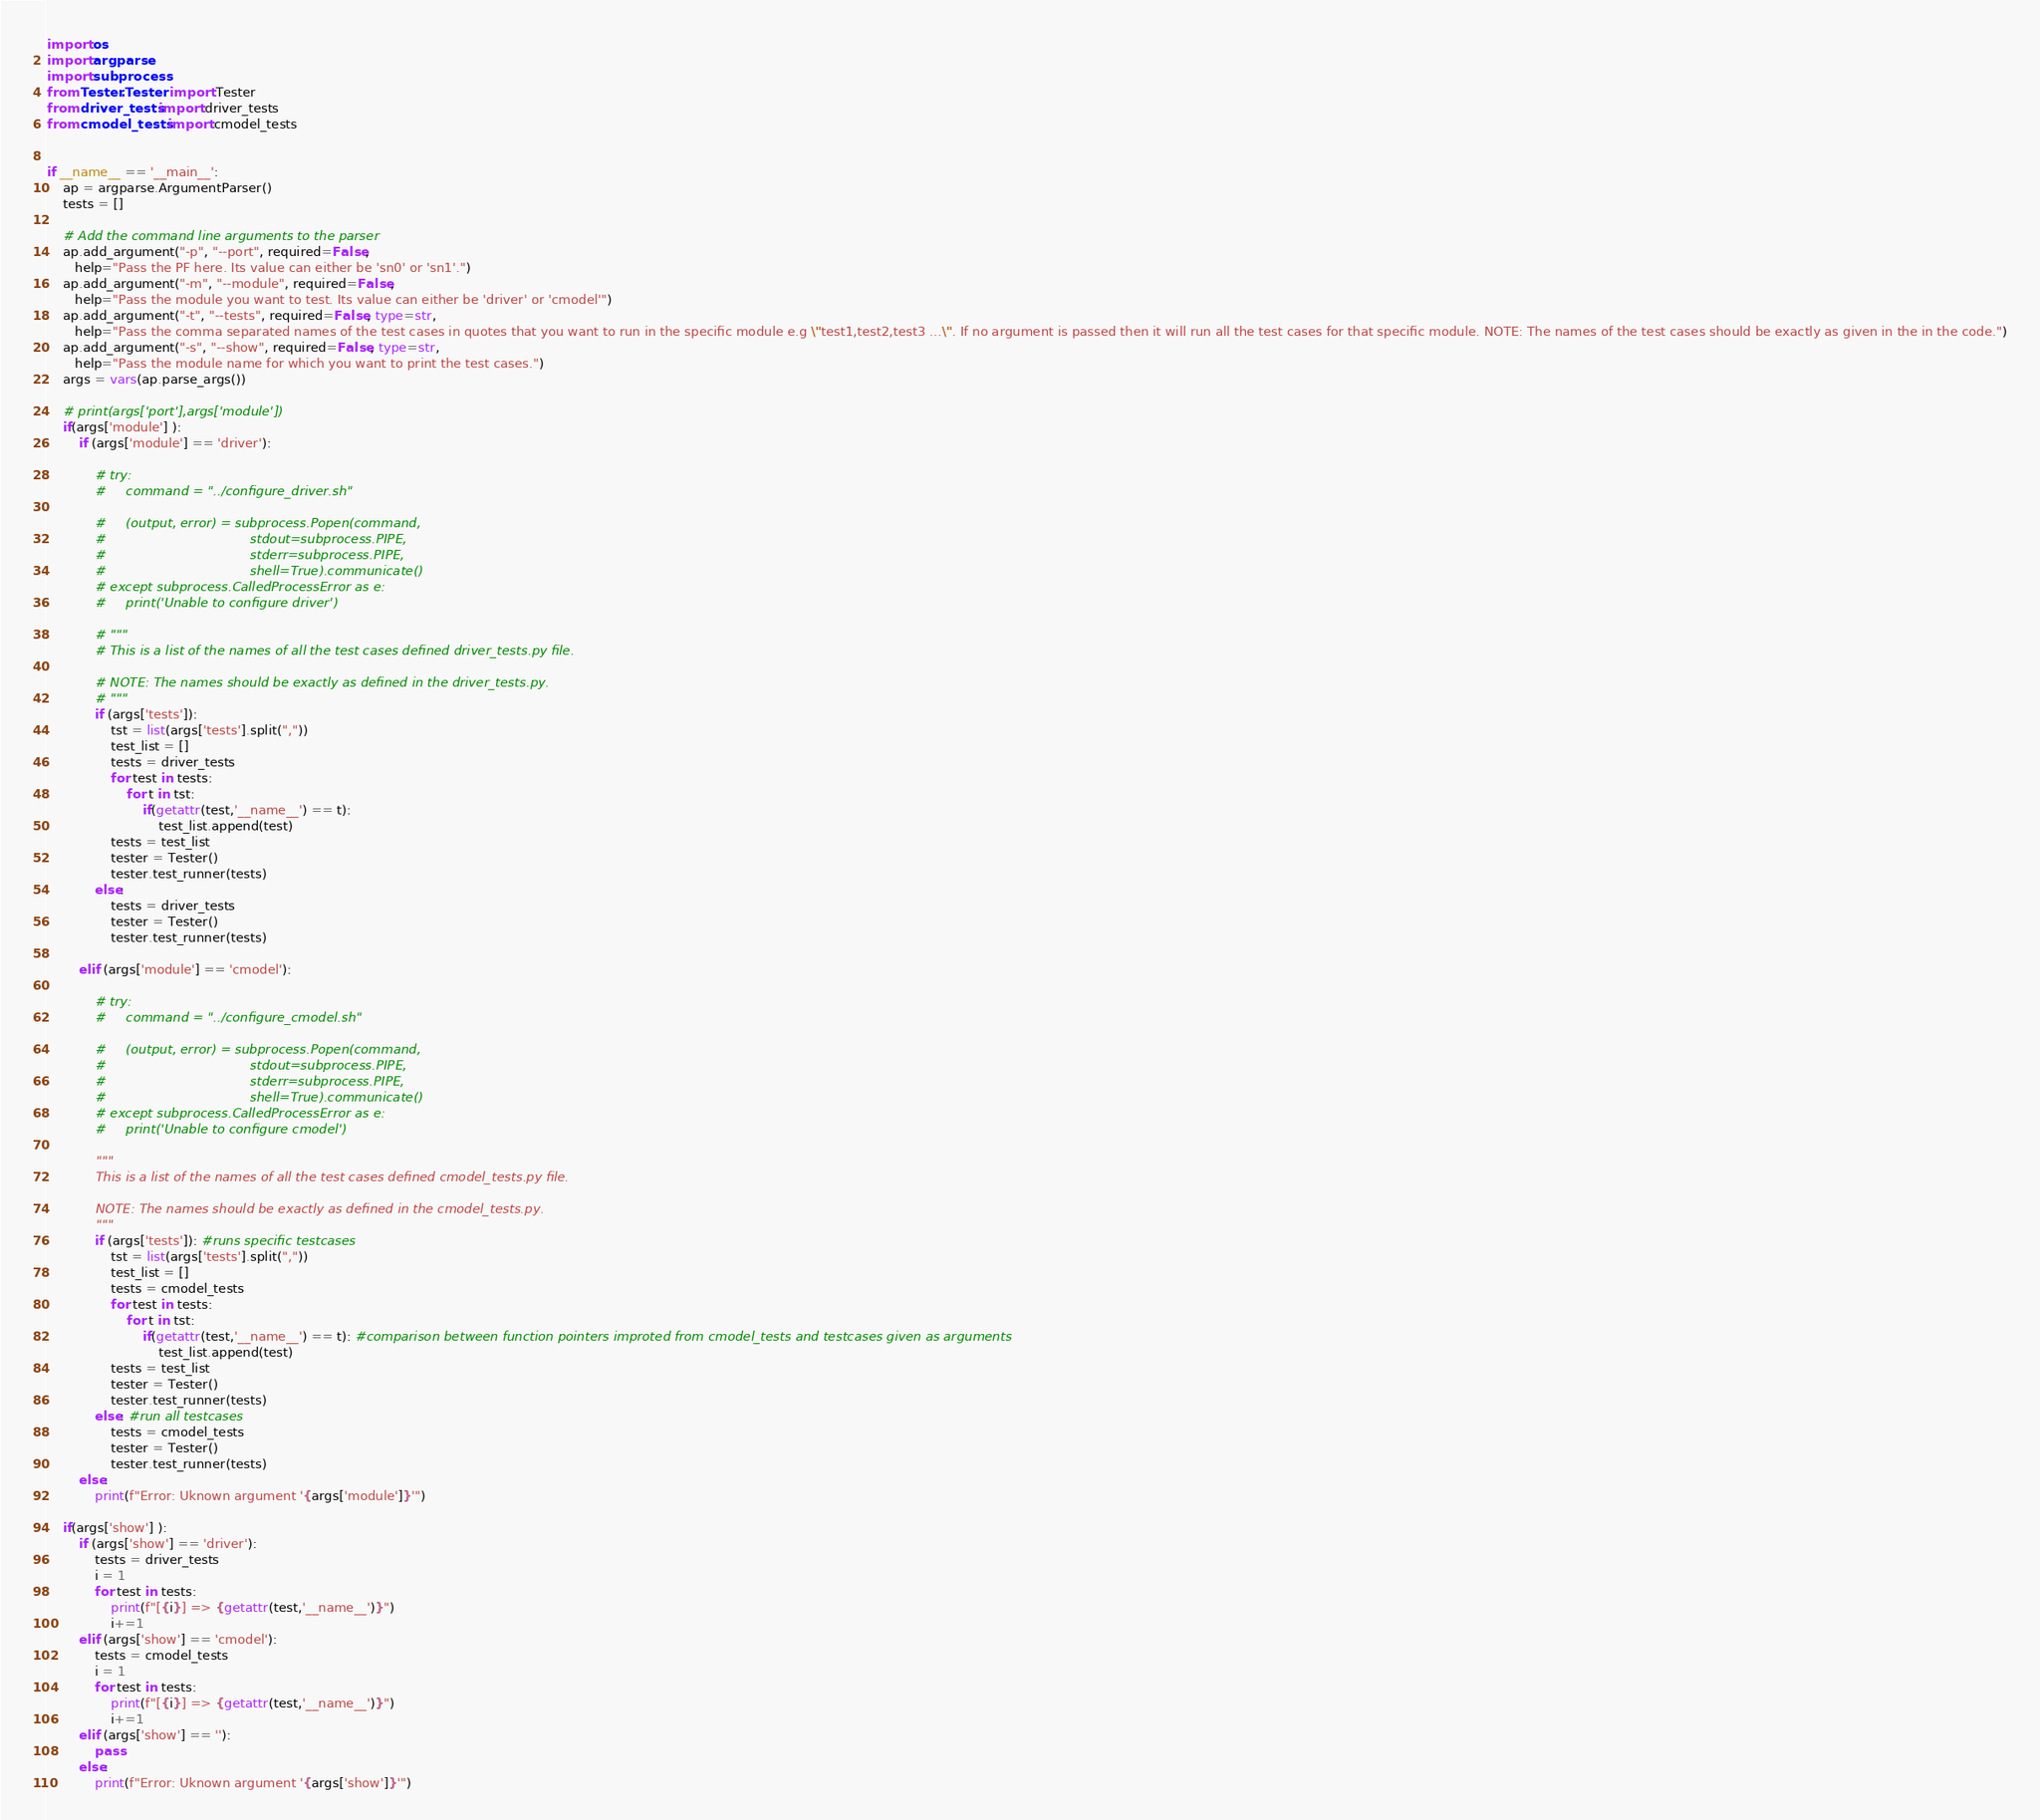<code> <loc_0><loc_0><loc_500><loc_500><_Python_>import os
import argparse
import subprocess
from Tester.Tester import Tester
from driver_tests import driver_tests
from cmodel_tests import cmodel_tests


if __name__ == '__main__':
    ap = argparse.ArgumentParser()
    tests = []

    # Add the command line arguments to the parser
    ap.add_argument("-p", "--port", required=False,
       help="Pass the PF here. Its value can either be 'sn0' or 'sn1'.")
    ap.add_argument("-m", "--module", required=False,
       help="Pass the module you want to test. Its value can either be 'driver' or 'cmodel'")
    ap.add_argument("-t", "--tests", required=False, type=str,
       help="Pass the comma separated names of the test cases in quotes that you want to run in the specific module e.g \"test1,test2,test3 ...\". If no argument is passed then it will run all the test cases for that specific module. NOTE: The names of the test cases should be exactly as given in the in the code.")
    ap.add_argument("-s", "--show", required=False, type=str,
       help="Pass the module name for which you want to print the test cases.")
    args = vars(ap.parse_args())

    # print(args['port'],args['module'])
    if(args['module'] ):
        if (args['module'] == 'driver'):
            
            # try:
            #     command = "../configure_driver.sh"

            #     (output, error) = subprocess.Popen(command,
            #                                    stdout=subprocess.PIPE,
            #                                    stderr=subprocess.PIPE,
            #                                    shell=True).communicate()
            # except subprocess.CalledProcessError as e:
            #     print('Unable to configure driver')

            # """
            # This is a list of the names of all the test cases defined driver_tests.py file.

            # NOTE: The names should be exactly as defined in the driver_tests.py.
            # """
            if (args['tests']):
                tst = list(args['tests'].split(","))
                test_list = []
                tests = driver_tests
                for test in tests:
                    for t in tst:
                        if(getattr(test,'__name__') == t):
                            test_list.append(test)
                tests = test_list
                tester = Tester()
                tester.test_runner(tests)
            else:
                tests = driver_tests
                tester = Tester()
                tester.test_runner(tests)

        elif (args['module'] == 'cmodel'):

            # try:
            #     command = "../configure_cmodel.sh"

            #     (output, error) = subprocess.Popen(command,
            #                                    stdout=subprocess.PIPE,
            #                                    stderr=subprocess.PIPE,
            #                                    shell=True).communicate()
            # except subprocess.CalledProcessError as e:
            #     print('Unable to configure cmodel')

            """
            This is a list of the names of all the test cases defined cmodel_tests.py file.

            NOTE: The names should be exactly as defined in the cmodel_tests.py.
            """
            if (args['tests']): #runs specific testcases
                tst = list(args['tests'].split(","))
                test_list = []
                tests = cmodel_tests
                for test in tests:
                    for t in tst:
                        if(getattr(test,'__name__') == t): #comparison between function pointers improted from cmodel_tests and testcases given as arguments
                            test_list.append(test)
                tests = test_list
                tester = Tester()
                tester.test_runner(tests)
            else: #run all testcases
                tests = cmodel_tests
                tester = Tester()
                tester.test_runner(tests)
        else:
            print(f"Error: Uknown argument '{args['module']}'")

    if(args['show'] ):
        if (args['show'] == 'driver'):
            tests = driver_tests
            i = 1
            for test in tests:
                print(f"[{i}] => {getattr(test,'__name__')}")
                i+=1
        elif (args['show'] == 'cmodel'):
            tests = cmodel_tests
            i = 1
            for test in tests:
                print(f"[{i}] => {getattr(test,'__name__')}")
                i+=1
        elif (args['show'] == ''):
            pass
        else:
            print(f"Error: Uknown argument '{args['show']}'")</code> 